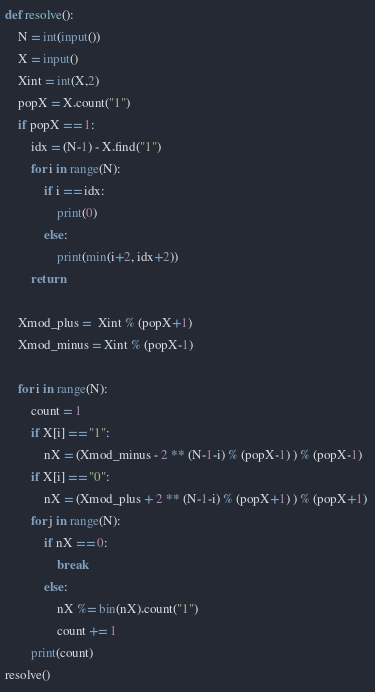Convert code to text. <code><loc_0><loc_0><loc_500><loc_500><_Python_>def resolve():
    N = int(input())
    X = input()
    Xint = int(X,2)
    popX = X.count("1")
    if popX == 1:
        idx = (N-1) - X.find("1")
        for i in range(N):
            if i == idx:
                print(0)
            else:
                print(min(i+2, idx+2))
        return

    Xmod_plus =  Xint % (popX+1)
    Xmod_minus = Xint % (popX-1)

    for i in range(N):
        count = 1
        if X[i] == "1":
            nX = (Xmod_minus - 2 ** (N-1-i) % (popX-1) ) % (popX-1) 
        if X[i] == "0":
            nX = (Xmod_plus + 2 ** (N-1-i) % (popX+1) ) % (popX+1) 
        for j in range(N):
            if nX == 0:
                break
            else:
                nX %= bin(nX).count("1")              
                count += 1
        print(count)
resolve()</code> 